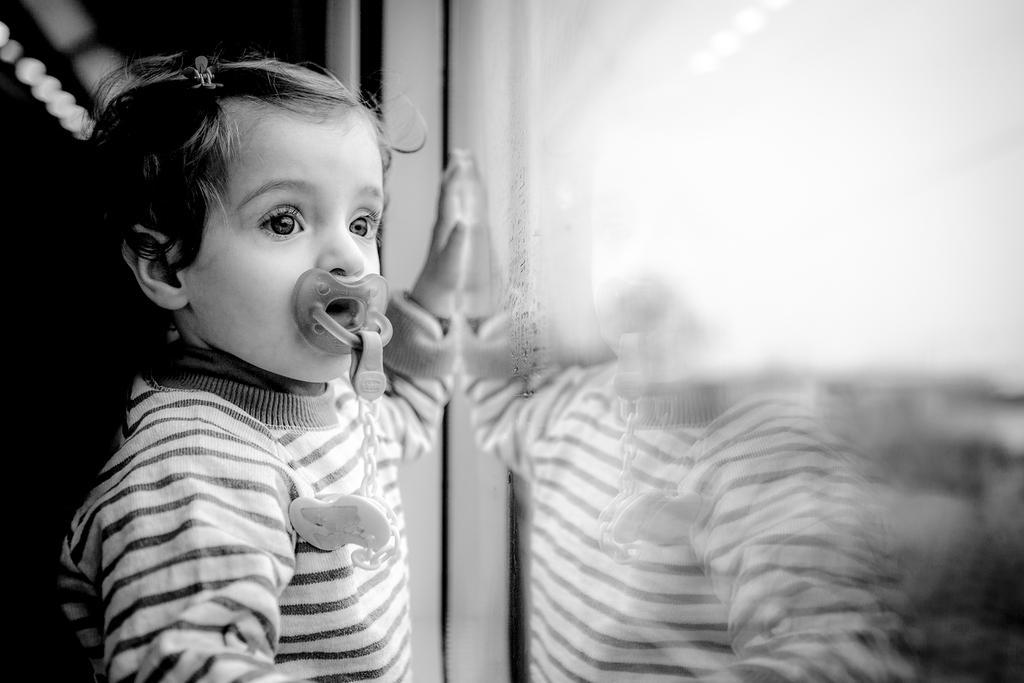Describe this image in one or two sentences. In this image, we can see a small kid standing and holding an object in the mouth. 